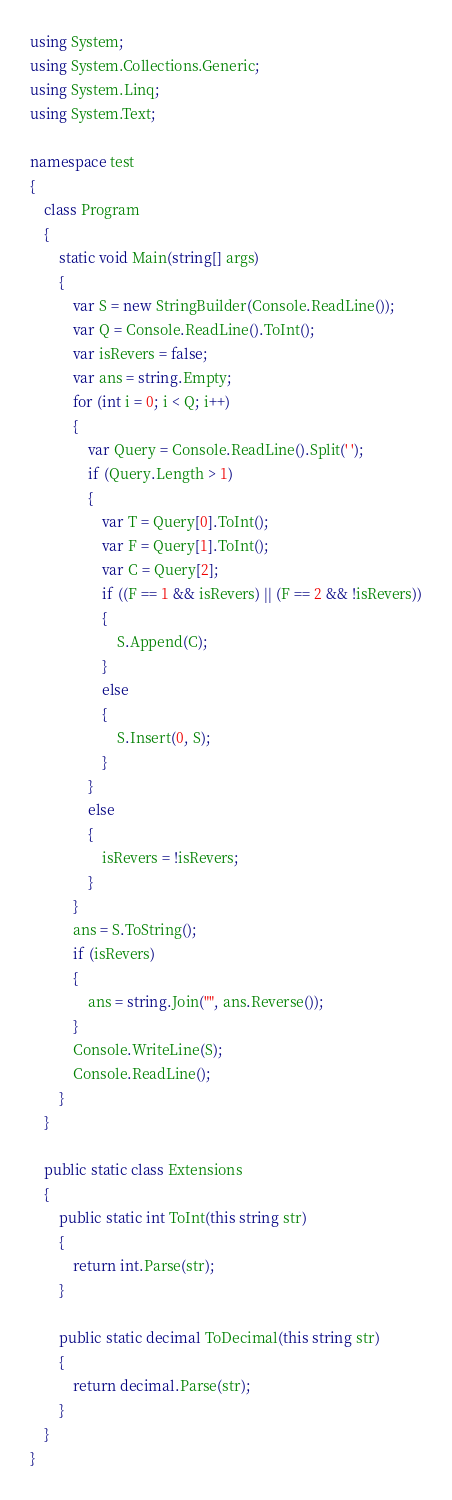Convert code to text. <code><loc_0><loc_0><loc_500><loc_500><_C#_>using System;
using System.Collections.Generic;
using System.Linq;
using System.Text;

namespace test
{
    class Program
    {
        static void Main(string[] args)
        {
            var S = new StringBuilder(Console.ReadLine());
            var Q = Console.ReadLine().ToInt();
            var isRevers = false;
            var ans = string.Empty;
            for (int i = 0; i < Q; i++)
            {
                var Query = Console.ReadLine().Split(' ');
                if (Query.Length > 1)
                {
                    var T = Query[0].ToInt();
                    var F = Query[1].ToInt();
                    var C = Query[2];
                    if ((F == 1 && isRevers) || (F == 2 && !isRevers))
                    {
                        S.Append(C);
                    }
                    else
                    {
                        S.Insert(0, S);
                    }
                }
                else
                {
                    isRevers = !isRevers;
                }
            }
            ans = S.ToString();
            if (isRevers)
            {
                ans = string.Join("", ans.Reverse());
            }
            Console.WriteLine(S);
            Console.ReadLine();
        }
    }

    public static class Extensions
    {
        public static int ToInt(this string str)
        {
            return int.Parse(str);
        }

        public static decimal ToDecimal(this string str)
        {
            return decimal.Parse(str);
        }
    }
}
</code> 